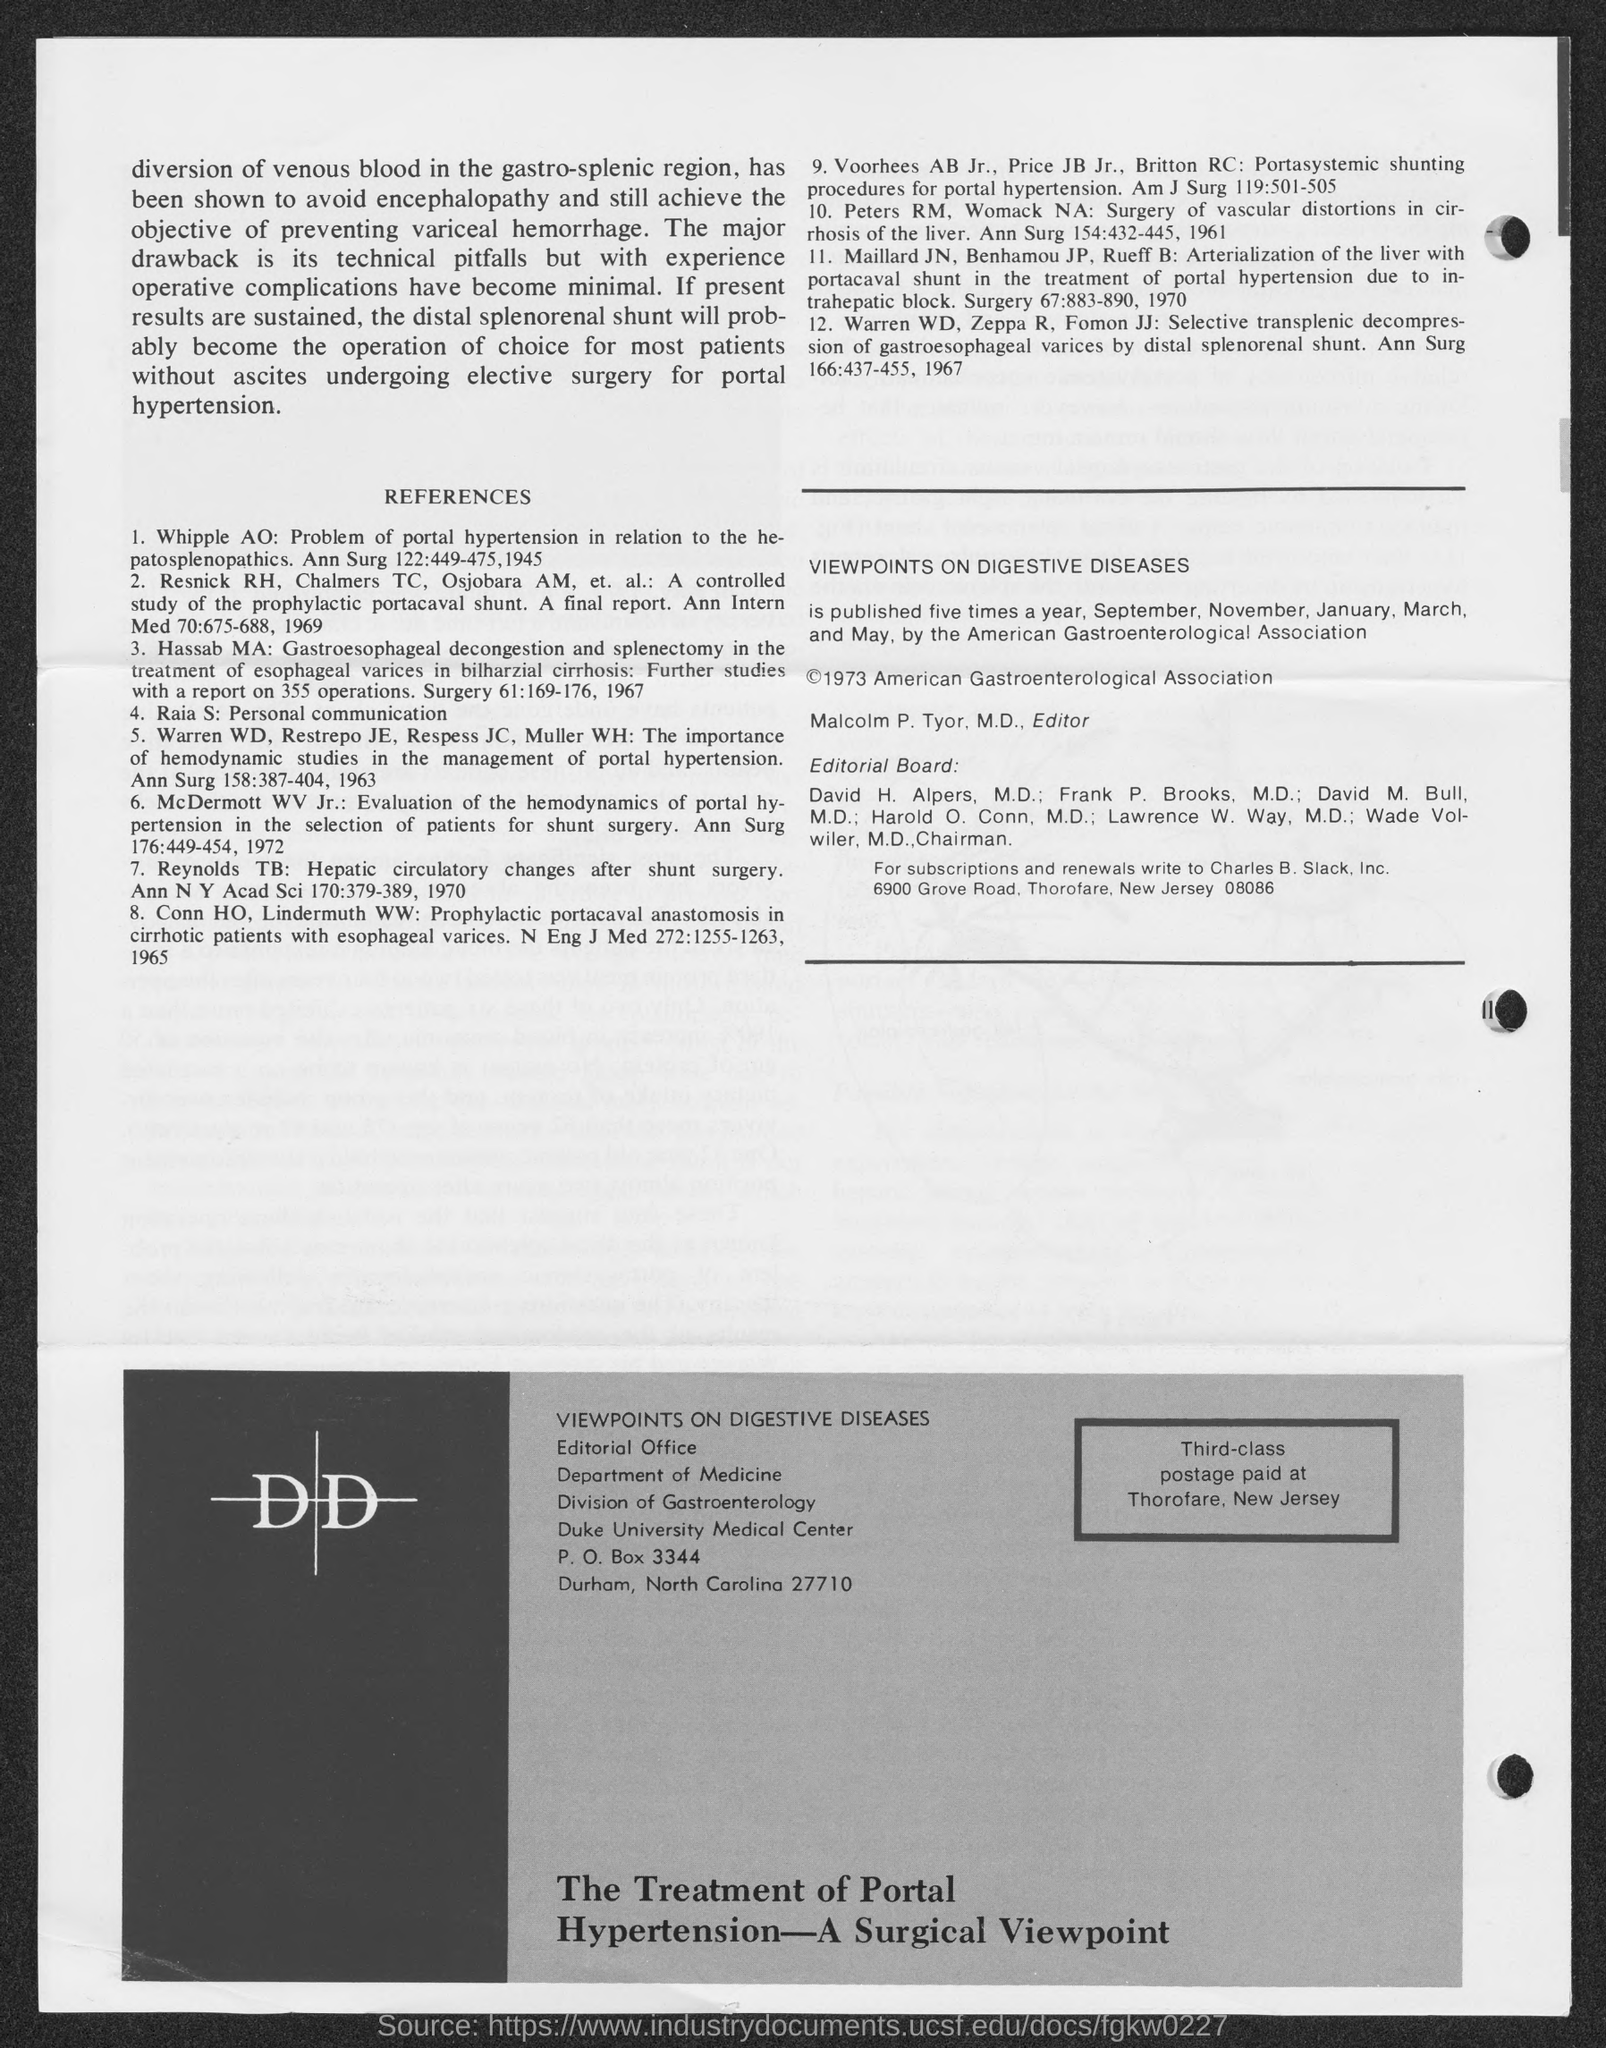What is the PO Box number mentioned in the document?
Make the answer very short. 3344. What is the first title in the document?
Provide a succinct answer. References. 